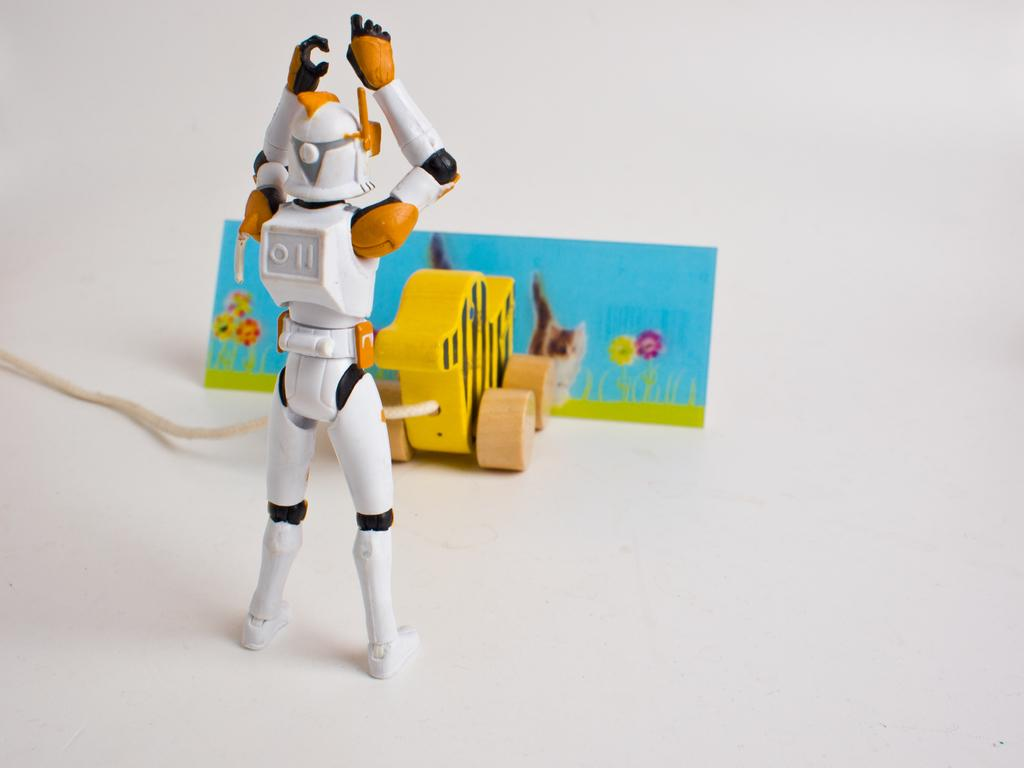What objects can be seen in the image? There are toys in the image. What color is the background of the image? The background of the image is white. How does the ray of light interact with the toys in the image? There is no ray of light present in the image; the background is white, but no light source is mentioned or visible. 